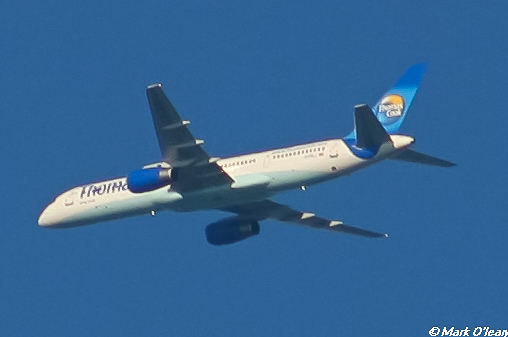<image>How big plane is this? It is unknown how big the plane is. The size estimation varies. How big plane is this? I don't know how big the plane is. It can be large, very large, big, huge, medium or very large. 